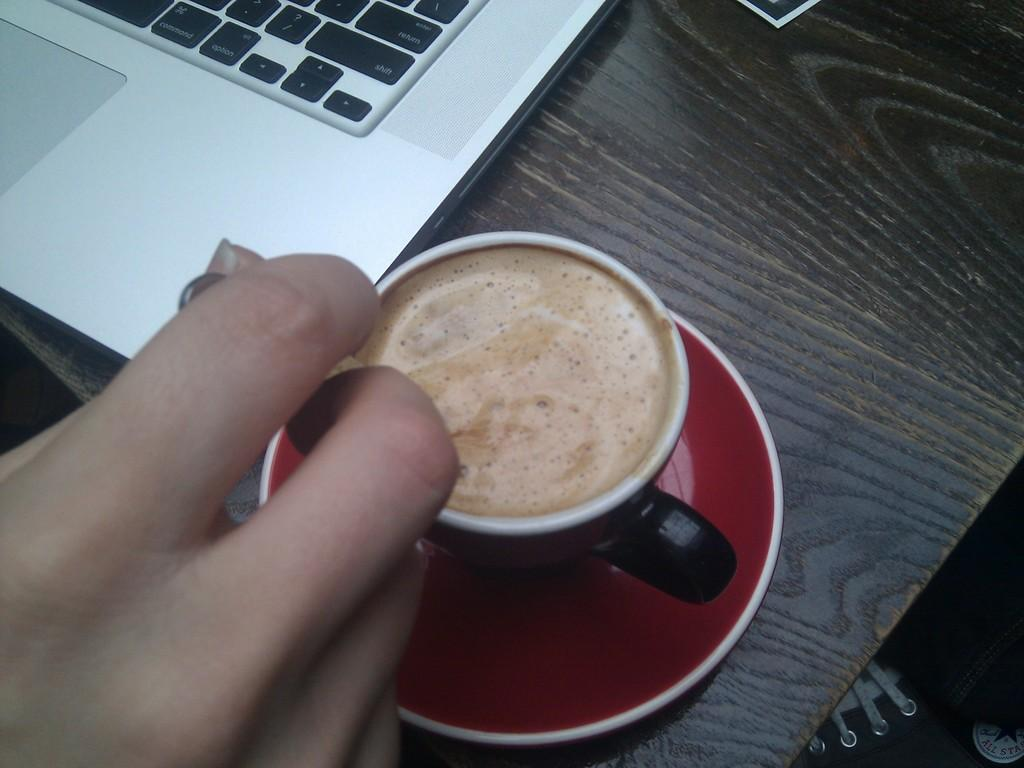What is the main object in the image? There is a wooden plank in the image. What is placed on the wooden plank? A laptop saucer and a cup are on the wooden plank. Can you describe the person's hand in the image? A person's hand holding a spoon is visible in the image, and it is in the left bottom part of the image. What else can be seen behind the wooden plank? There is a shoe behind the wooden plank. What type of fan is visible in the image? There is no fan present in the image. Can you describe the friend sitting next to the person in the image? There is no friend present in the image; only a person's hand holding a spoon is visible. 